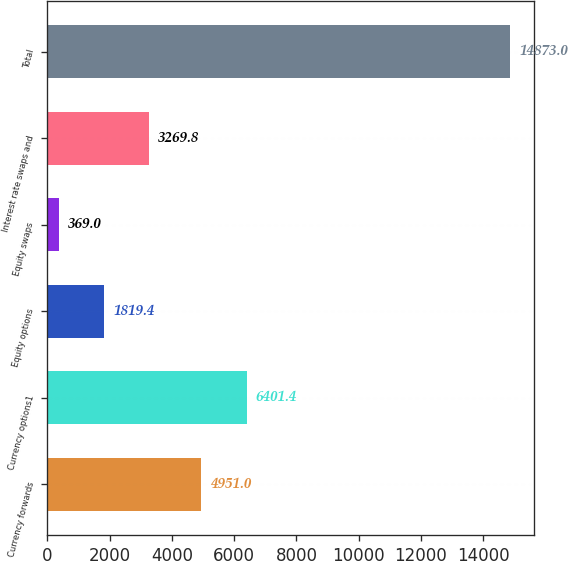<chart> <loc_0><loc_0><loc_500><loc_500><bar_chart><fcel>Currency forwards<fcel>Currency options1<fcel>Equity options<fcel>Equity swaps<fcel>Interest rate swaps and<fcel>Total<nl><fcel>4951<fcel>6401.4<fcel>1819.4<fcel>369<fcel>3269.8<fcel>14873<nl></chart> 